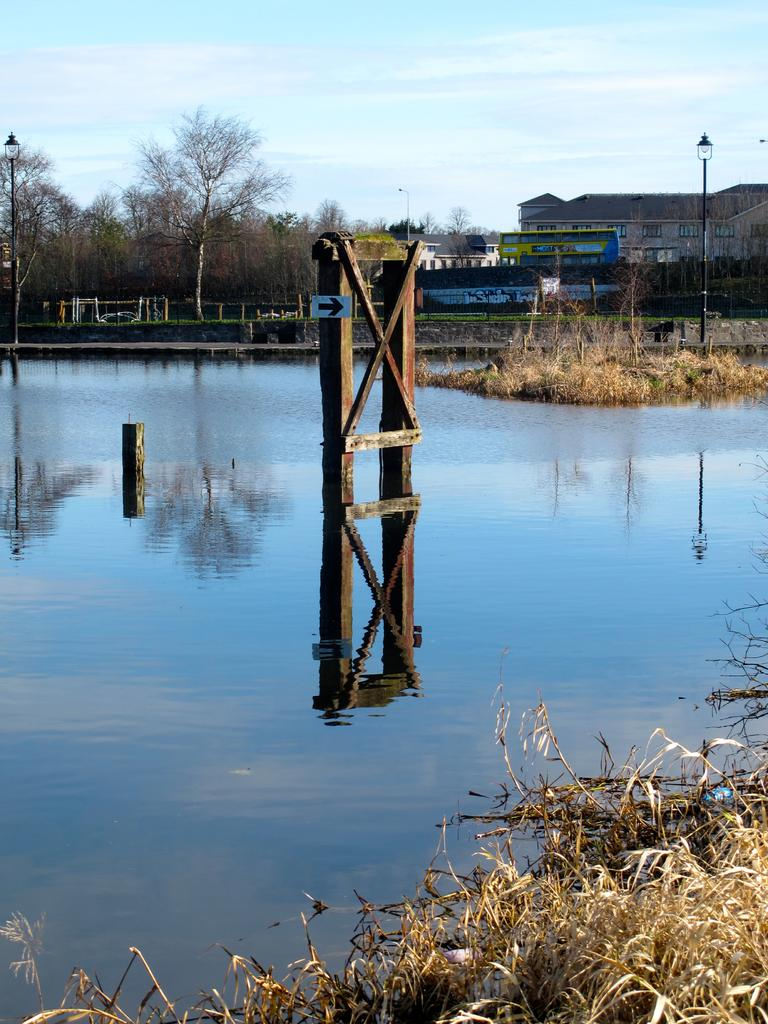What is on the wooden object in the image? There is an arrow sign on a wooden object in the image. What type of lighting is present in the image? There are street lights visible in the image. What can be seen in the background of the image? There are trees and buildings in the background of the image. What type of vegetation is visible in the image? There is grass visible in the image. What natural element is visible in the image? There is water visible in the image. What type of suit is the geese wearing in the image? There are no geese or suits present in the image. How does the wind affect the water in the image? There is no indication of wind in the image, so its effect on the water cannot be determined. 